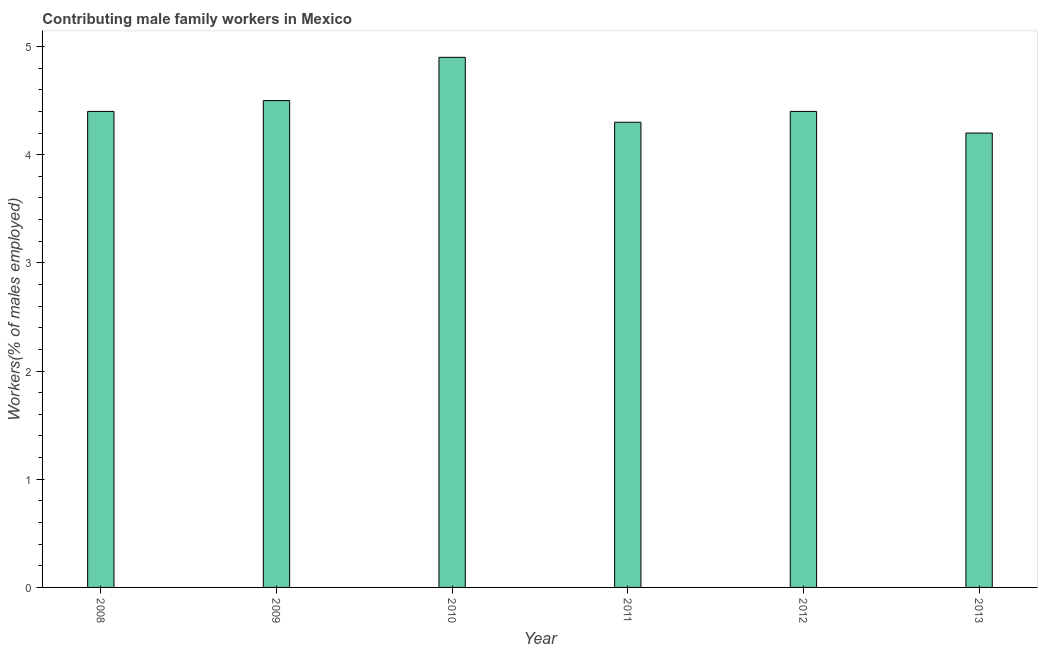What is the title of the graph?
Your answer should be compact. Contributing male family workers in Mexico. What is the label or title of the Y-axis?
Provide a short and direct response. Workers(% of males employed). What is the contributing male family workers in 2012?
Offer a terse response. 4.4. Across all years, what is the maximum contributing male family workers?
Keep it short and to the point. 4.9. Across all years, what is the minimum contributing male family workers?
Make the answer very short. 4.2. What is the sum of the contributing male family workers?
Your answer should be very brief. 26.7. What is the average contributing male family workers per year?
Make the answer very short. 4.45. What is the median contributing male family workers?
Ensure brevity in your answer.  4.4. What is the ratio of the contributing male family workers in 2010 to that in 2011?
Make the answer very short. 1.14. Is the contributing male family workers in 2009 less than that in 2012?
Make the answer very short. No. Is the difference between the contributing male family workers in 2010 and 2013 greater than the difference between any two years?
Ensure brevity in your answer.  Yes. What is the difference between the highest and the second highest contributing male family workers?
Make the answer very short. 0.4. What is the difference between the highest and the lowest contributing male family workers?
Your answer should be very brief. 0.7. Are all the bars in the graph horizontal?
Make the answer very short. No. What is the difference between two consecutive major ticks on the Y-axis?
Make the answer very short. 1. What is the Workers(% of males employed) in 2008?
Keep it short and to the point. 4.4. What is the Workers(% of males employed) in 2009?
Your answer should be very brief. 4.5. What is the Workers(% of males employed) in 2010?
Make the answer very short. 4.9. What is the Workers(% of males employed) in 2011?
Provide a succinct answer. 4.3. What is the Workers(% of males employed) in 2012?
Keep it short and to the point. 4.4. What is the Workers(% of males employed) of 2013?
Make the answer very short. 4.2. What is the difference between the Workers(% of males employed) in 2008 and 2009?
Ensure brevity in your answer.  -0.1. What is the difference between the Workers(% of males employed) in 2008 and 2010?
Your answer should be compact. -0.5. What is the difference between the Workers(% of males employed) in 2008 and 2011?
Offer a very short reply. 0.1. What is the difference between the Workers(% of males employed) in 2008 and 2013?
Give a very brief answer. 0.2. What is the difference between the Workers(% of males employed) in 2009 and 2011?
Give a very brief answer. 0.2. What is the difference between the Workers(% of males employed) in 2009 and 2012?
Your answer should be compact. 0.1. What is the difference between the Workers(% of males employed) in 2010 and 2011?
Make the answer very short. 0.6. What is the ratio of the Workers(% of males employed) in 2008 to that in 2009?
Make the answer very short. 0.98. What is the ratio of the Workers(% of males employed) in 2008 to that in 2010?
Your answer should be very brief. 0.9. What is the ratio of the Workers(% of males employed) in 2008 to that in 2011?
Your answer should be compact. 1.02. What is the ratio of the Workers(% of males employed) in 2008 to that in 2013?
Your response must be concise. 1.05. What is the ratio of the Workers(% of males employed) in 2009 to that in 2010?
Keep it short and to the point. 0.92. What is the ratio of the Workers(% of males employed) in 2009 to that in 2011?
Ensure brevity in your answer.  1.05. What is the ratio of the Workers(% of males employed) in 2009 to that in 2013?
Provide a succinct answer. 1.07. What is the ratio of the Workers(% of males employed) in 2010 to that in 2011?
Offer a very short reply. 1.14. What is the ratio of the Workers(% of males employed) in 2010 to that in 2012?
Keep it short and to the point. 1.11. What is the ratio of the Workers(% of males employed) in 2010 to that in 2013?
Make the answer very short. 1.17. What is the ratio of the Workers(% of males employed) in 2011 to that in 2012?
Your answer should be compact. 0.98. What is the ratio of the Workers(% of males employed) in 2011 to that in 2013?
Your answer should be very brief. 1.02. What is the ratio of the Workers(% of males employed) in 2012 to that in 2013?
Your response must be concise. 1.05. 